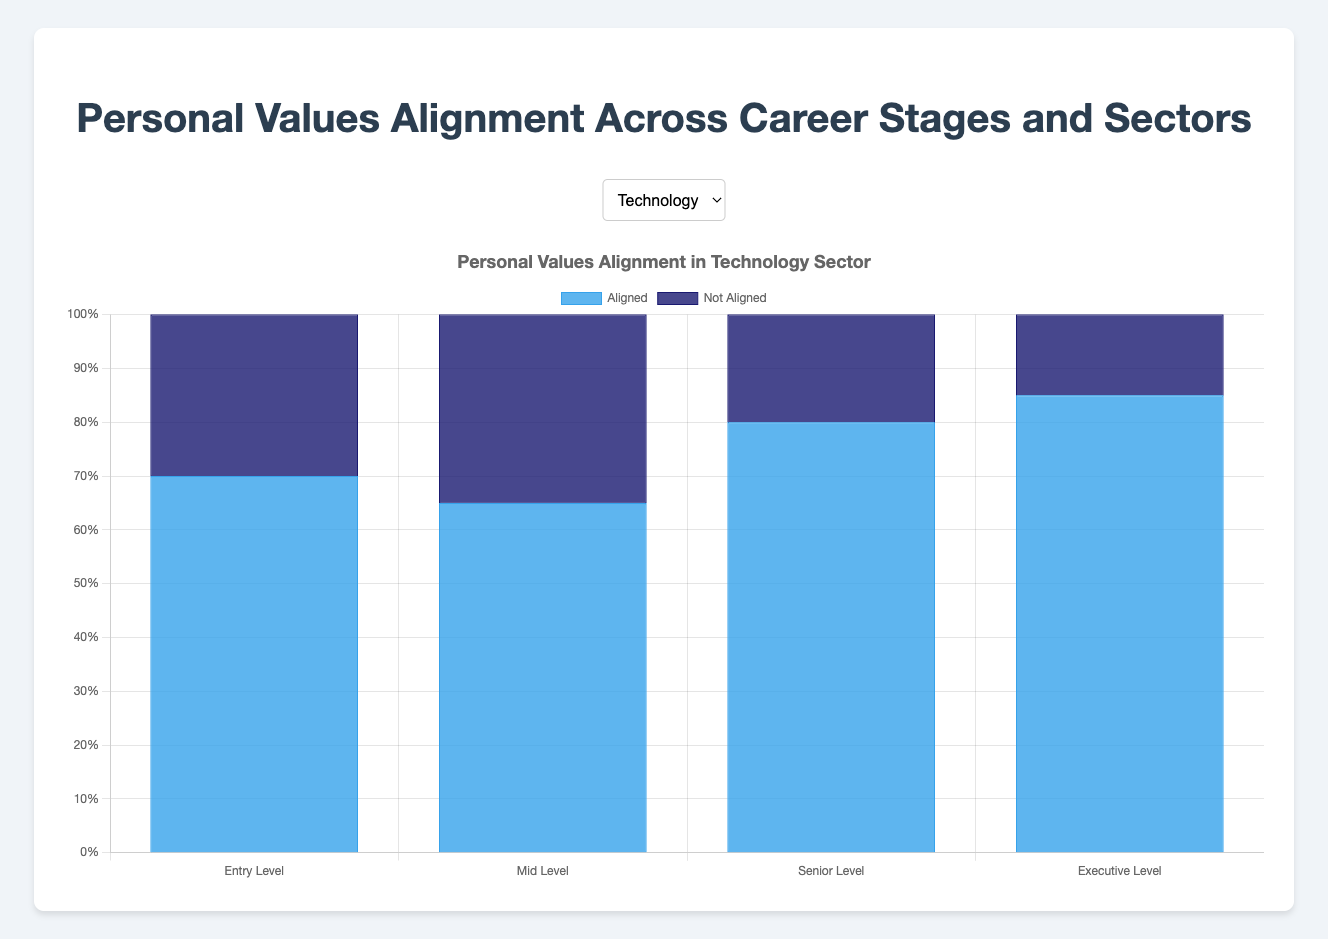Which career stage in the Technology sector has the highest alignment percentage? The highest alignment percentage is found by comparing the "Aligned" values across all career stages in the Technology sector. The stages and their alignment percentages are: Entry Level (70%), Mid Level (65%), Senior Level (80%), and Executive Level (85%). The highest percentage is 85% at the Executive Level.
Answer: Executive Level In the Finance sector, what is the combined alignment percentage for Entry Level and Mid Level? Find the aligned values for Entry Level (50%) and Mid Level (60%) in the Finance sector and sum them up: 50% + 60% = 110%. Since we are asked for the combined alignment percentage, the values should be added this way.
Answer: 110% Which sector shows the least alignment at the Senior Level? Compare the "Aligned" percentages for Senior Level across all sectors: Technology (80%), Healthcare (70%), Finance (65%), Education (85%), and Nonprofit (90%). The least percentage is 65% in the Finance sector.
Answer: Finance Does Executive Level in the Nonprofit sector have a higher alignment percentage compared to the Healthcare sector at the same level? Compare the Executive Level "Aligned" percentages for Nonprofit (95%) and Healthcare (75%). Since 95% is greater than 75%, the alignment is higher in the Nonprofit sector.
Answer: Yes How do the alignment percentages in the Education sector compare between Mid Level and Senior Level? Check the "Aligned" percentages for Mid Level (75%) and Senior Level (85%) in the Education sector. Since 85% is greater than 75%, the alignment is higher at the Senior Level.
Answer: Higher at Senior Level What is the difference in alignment percentage between Entry Level and Executive Level in the Healthcare sector? Subtract the "Aligned" value for Entry Level (60%) from the value for Executive Level (75%): 75% - 60% = 15%.
Answer: 15% In the Technology sector, by how much does the alignment percentage increase from Mid Level to Senior Level? Find the difference in the "Aligned" values between Senior Level (80%) and Mid Level (65%) in the Technology sector: 80% - 65% = 15%.
Answer: 15% Which sector has the highest overall alignment at Entry Level based on the provided data? Compare the Entry Level "Aligned" percentages across all sectors: Technology (70%), Healthcare (60%), Finance (50%), Education (80%), and Nonprofit (90%). The highest percentage is 90% in the Nonprofit sector.
Answer: Nonprofit How does the alignment percentage at Mid Level compare between the Finance and Education sectors? Compare the Mid Level "Aligned" percentages for Finance (60%) and Education (75%). Since 75% is greater than 60%, the alignment is higher in the Education sector.
Answer: Higher in Education What is the average alignment percentage at the Executive Level across all sectors? Sum the "Aligned" percentages for Executive Level across all sectors (85% for Technology, 75% for Healthcare, 70% for Finance, 90% for Education, 95% for Nonprofit) and divide by 5: (85% + 75% + 70% + 90% + 95%) / 5 = 83%.
Answer: 83% 